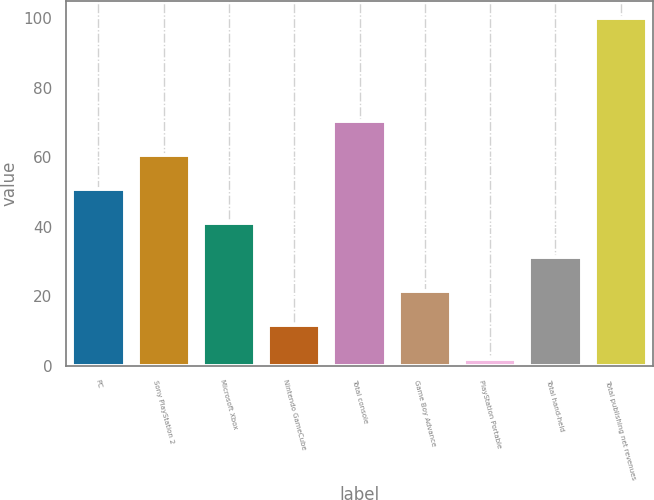Convert chart to OTSL. <chart><loc_0><loc_0><loc_500><loc_500><bar_chart><fcel>PC<fcel>Sony PlayStation 2<fcel>Microsoft Xbox<fcel>Nintendo GameCube<fcel>Total console<fcel>Game Boy Advance<fcel>PlayStation Portable<fcel>Total hand-held<fcel>Total publishing net revenues<nl><fcel>51<fcel>60.8<fcel>41.2<fcel>11.8<fcel>70.6<fcel>21.6<fcel>2<fcel>31.4<fcel>100<nl></chart> 